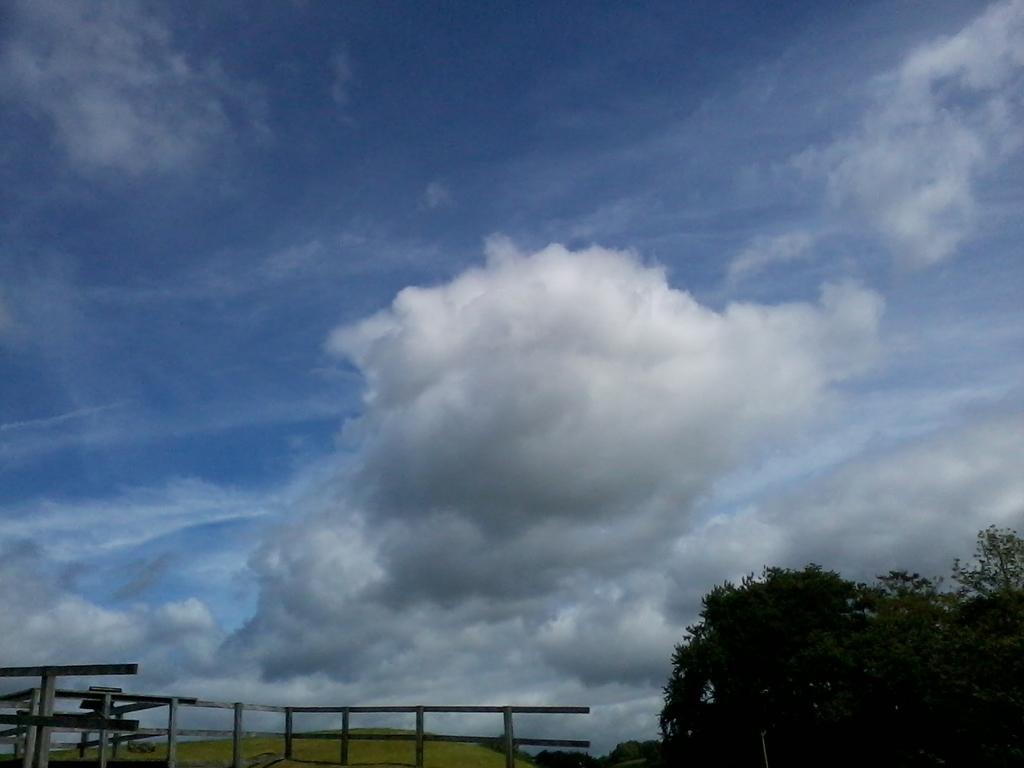What is the condition of the sky in the image? The sky in the image is cloudy. What type of barrier can be seen at the bottom of the image? There is a wooden fence at the bottom of the image. Where are the trees located in the image? Trees are present in the bottom right corner of the image. What type of wire is being used by the achiever in the image? There is no achiever or wire present in the image. 